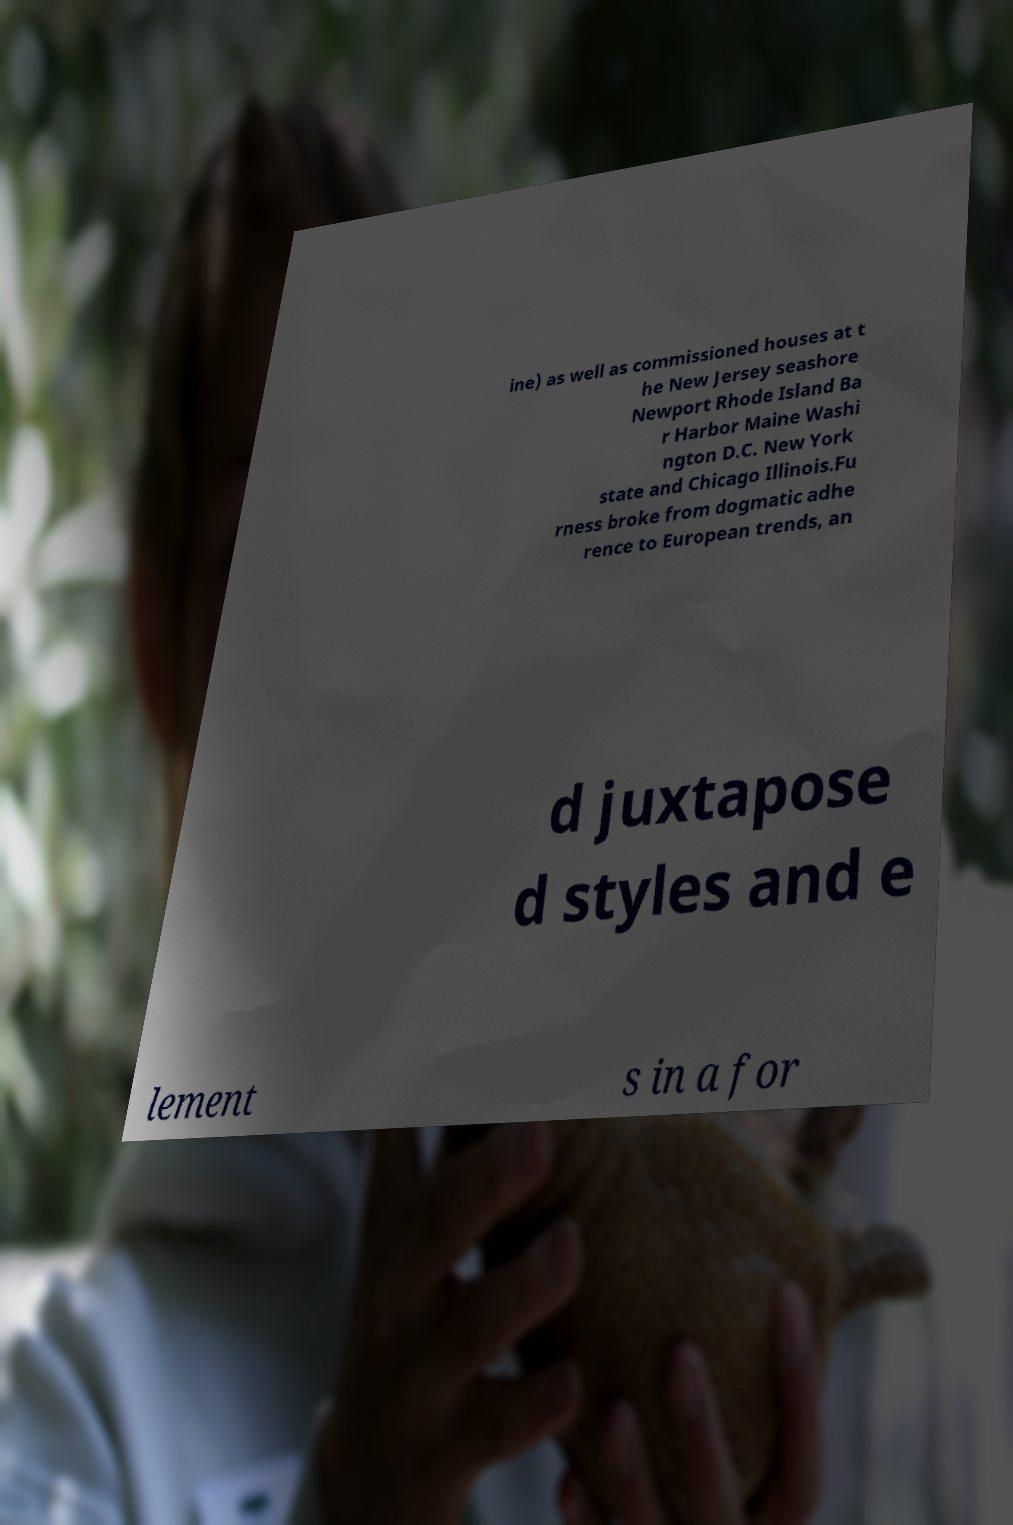Please identify and transcribe the text found in this image. ine) as well as commissioned houses at t he New Jersey seashore Newport Rhode Island Ba r Harbor Maine Washi ngton D.C. New York state and Chicago Illinois.Fu rness broke from dogmatic adhe rence to European trends, an d juxtapose d styles and e lement s in a for 